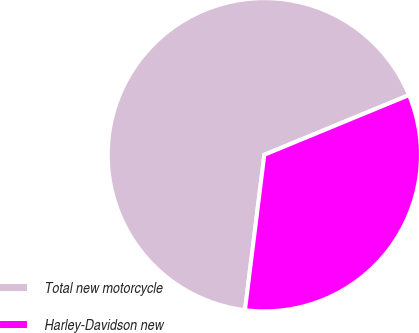Convert chart. <chart><loc_0><loc_0><loc_500><loc_500><pie_chart><fcel>Total new motorcycle<fcel>Harley-Davidson new<nl><fcel>66.8%<fcel>33.2%<nl></chart> 